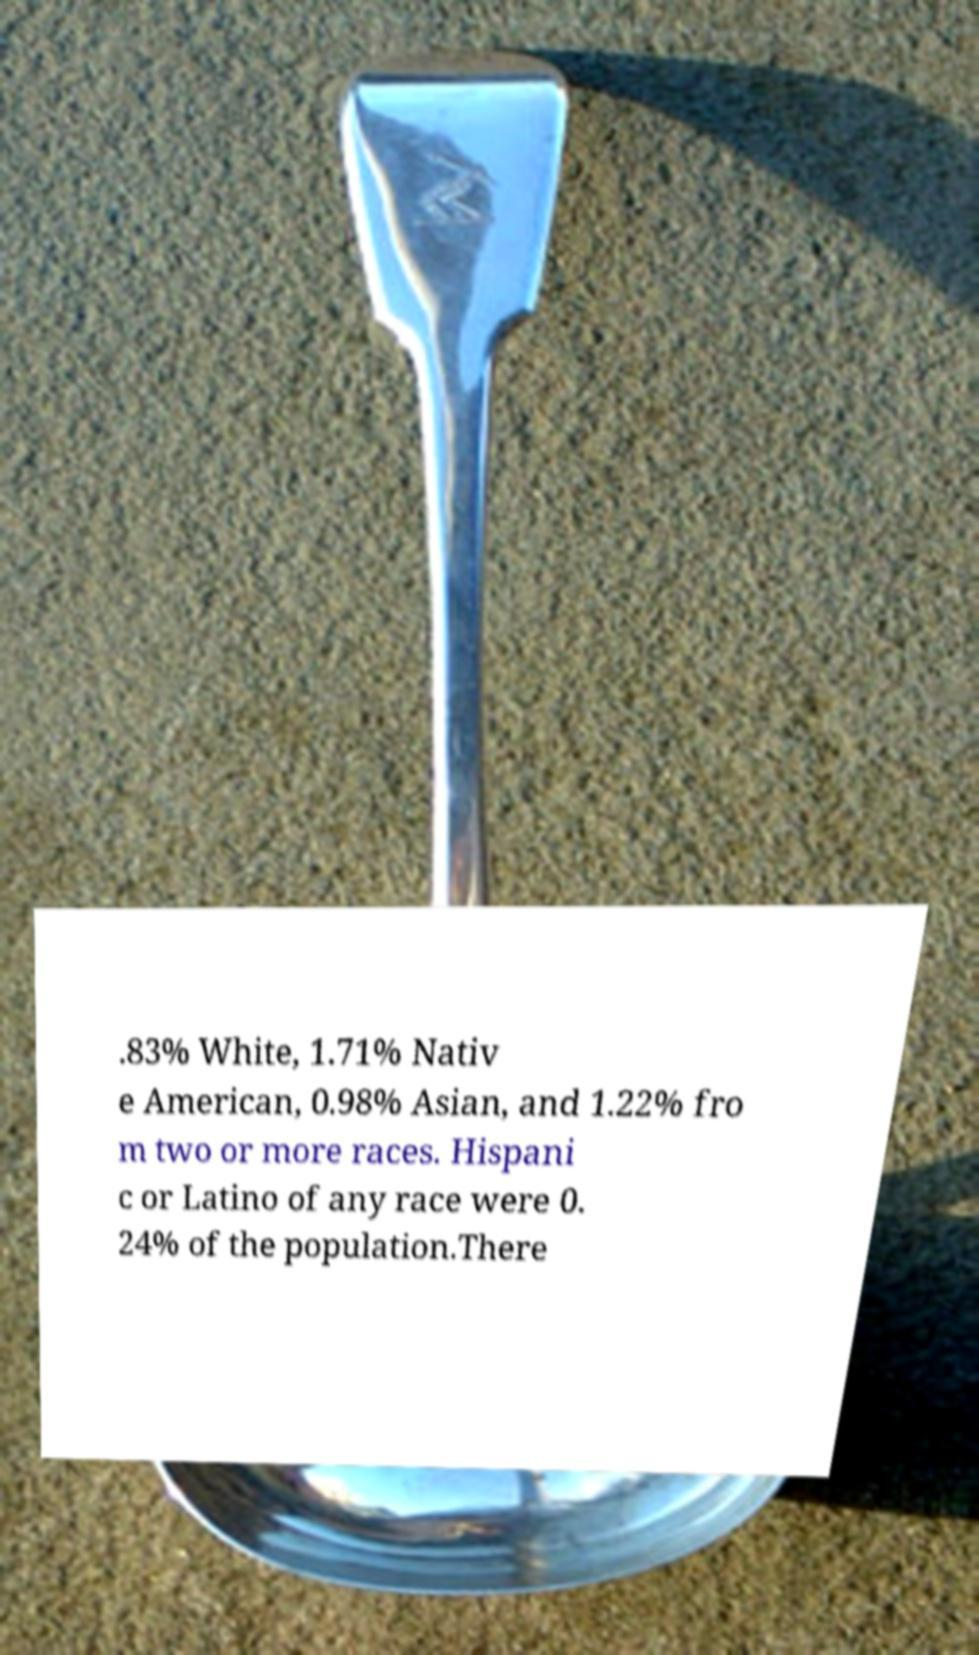For documentation purposes, I need the text within this image transcribed. Could you provide that? .83% White, 1.71% Nativ e American, 0.98% Asian, and 1.22% fro m two or more races. Hispani c or Latino of any race were 0. 24% of the population.There 